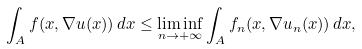<formula> <loc_0><loc_0><loc_500><loc_500>\int _ { A } f ( x , \nabla u ( x ) ) \, d x \leq \liminf _ { n \to + \infty } \int _ { A } f _ { n } ( x , \nabla u _ { n } ( x ) ) \, d x ,</formula> 